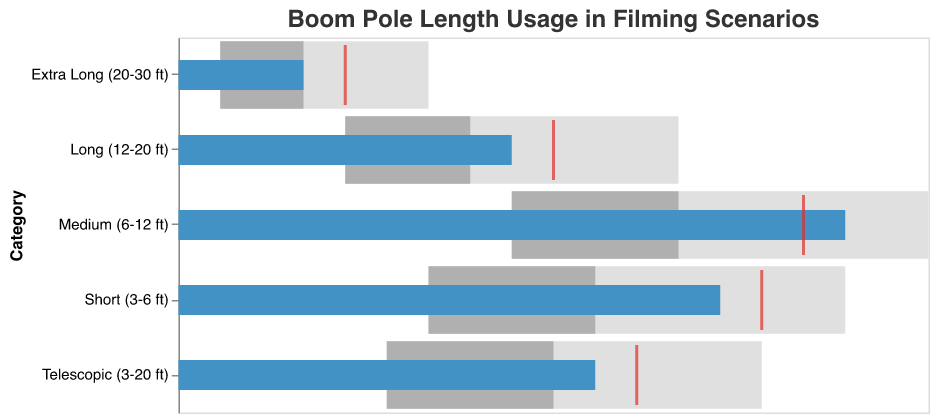What's the title of the chart? The title is displayed at the top of the chart and describes the content it represents. The title for this chart is "Boom Pole Length Usage in Filming Scenarios".
Answer: Boom Pole Length Usage in Filming Scenarios Which boom pole length category has the highest actual usage? The "Medium (6-12 ft)" category has an actual usage value of 80, represented by the blue bar, which is the highest among all the categories.
Answer: Medium (6-12 ft) How does the actual usage for "Telescopic (3-20 ft)" compare to its comparative usage? The actual usage for "Telescopic (3-20 ft)" is 50, represented by the blue bar, and the comparative usage is 55, marked by a red tick. Therefore, the actual usage is 5 units less than the comparative usage.
Answer: 5 units less Which boom pole length category has the smallest variation between its minimum and maximum range values? The "Extra Long (20-30 ft)" category has minimum and maximum range values of 5 and 30, respectively, yielding a variation of 25 units. This is the smallest variation among all categories.
Answer: Extra Long (20-30 ft) What are the intermediate range values for "Short (3-6 ft)" and "Medium (6-12 ft)"? For "Short (3-6 ft)", the ranges are 30, 50, and 80. For "Medium (6-12 ft)", the ranges are 40, 60, and 90. The intermediate range values are 50 for Short and 60 for Medium.
Answer: 50 for Short and 60 for Medium How many categories have actual usage values above their comparative usage values? By examining each category, only the "Medium (6-12 ft)" shows an actual usage (80) above its comparative usage (75).
Answer: 1 category If only the Short and Long categories are considered, what is their average actual usage? The actual usages for Short (65) and Long (40) sum up to 105. The average actual usage is calculated as 105 divided by 2.
Answer: 52.5 Which category falls entirely within the middle range? The "Telescopic (3-20 ft)" category has ranges of 25, 45, and 70, with an actual usage (50) and a comparative usage (55) both falling within the middle range boundary.
Answer: Telescopic (3-20 ft) What is the smallest actual usage across all categories? By looking at the actual usage values, the smallest is 15, which belongs to the "Extra Long (20-30 ft)" category.
Answer: 15 